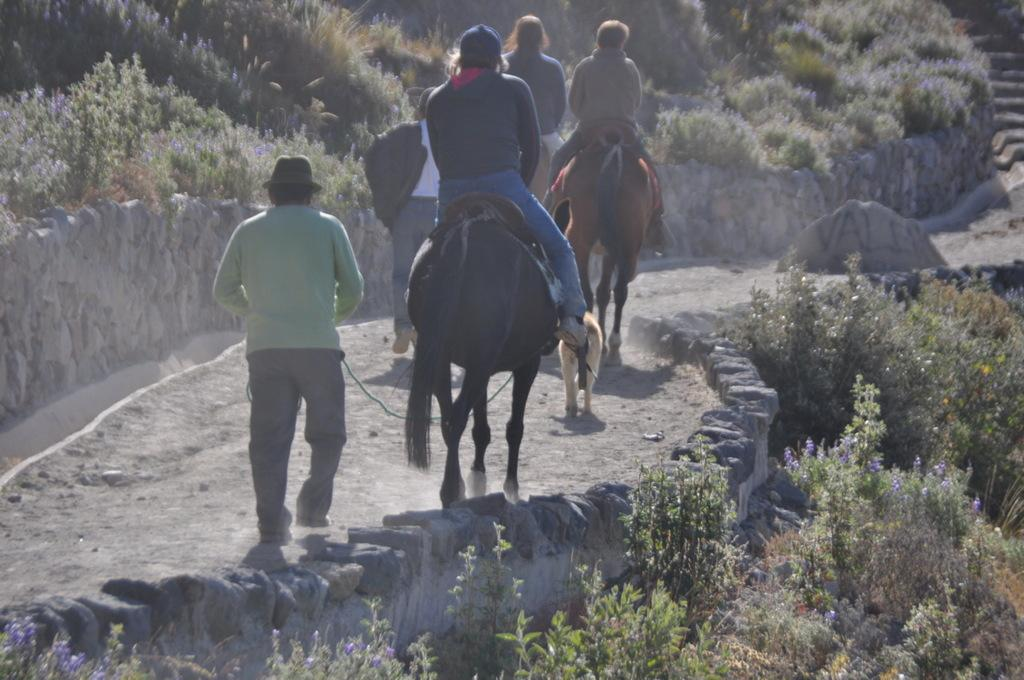What are the three persons in the image doing? The three persons are riding horses in the image. What other animal is present in the image? There is a dog in the image. What are the two persons on the path doing? The two persons are walking on a path in the image. What can be seen on both sides of the path? There are plants on both sides of the path. What architectural feature is visible in the image? There are steps in the image. What type of cap is the dog wearing in the image? There is no cap present on the dog in the image. How many eggs can be seen in the image? There are no eggs visible in the image. 